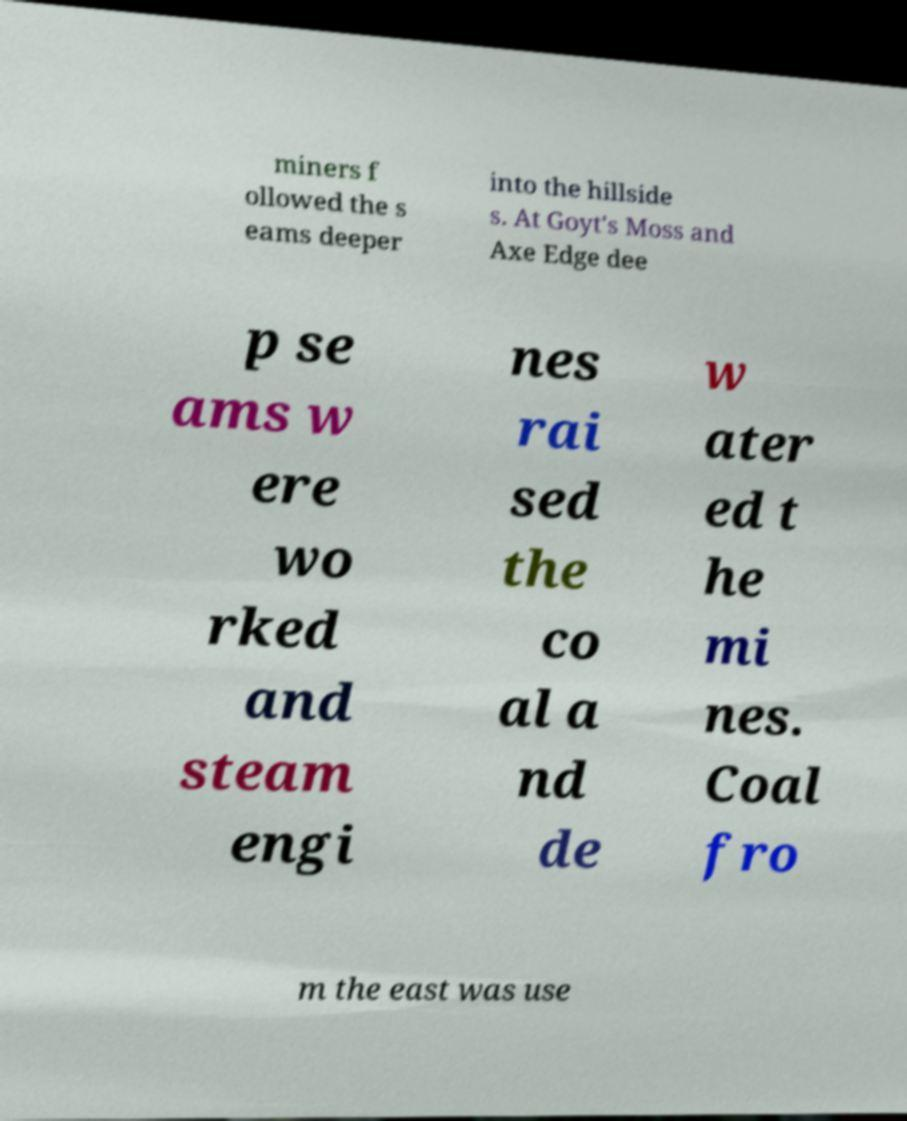Please read and relay the text visible in this image. What does it say? miners f ollowed the s eams deeper into the hillside s. At Goyt's Moss and Axe Edge dee p se ams w ere wo rked and steam engi nes rai sed the co al a nd de w ater ed t he mi nes. Coal fro m the east was use 